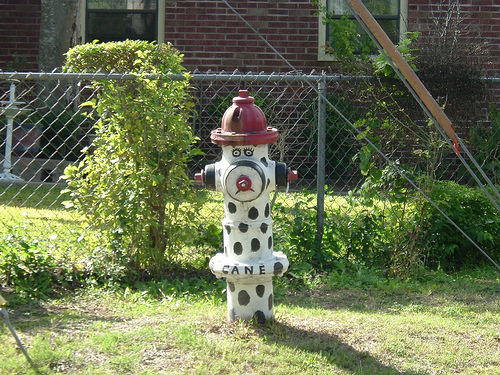Read all the text in this image. CANE 